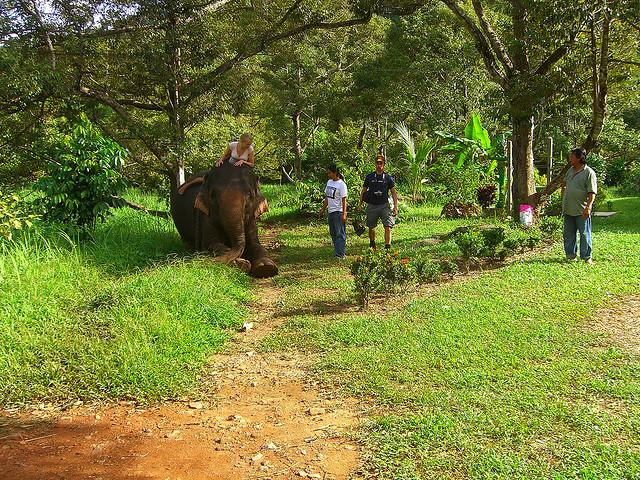Why is the elephant laying down on the left with the tourist on top? resting 